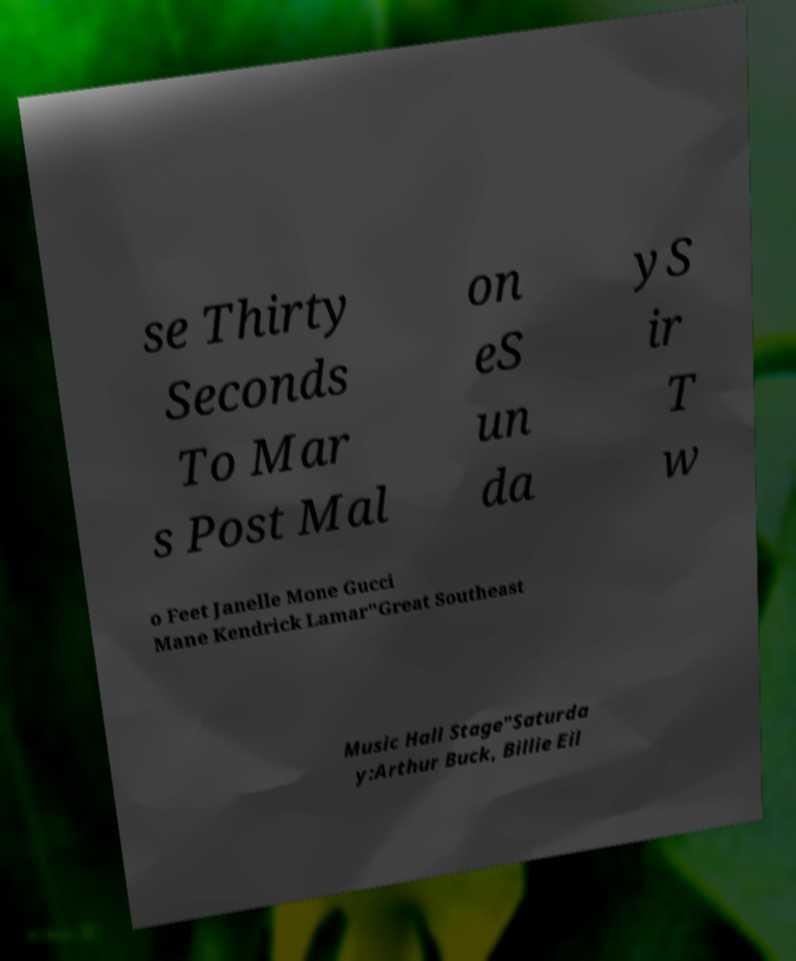I need the written content from this picture converted into text. Can you do that? se Thirty Seconds To Mar s Post Mal on eS un da yS ir T w o Feet Janelle Mone Gucci Mane Kendrick Lamar"Great Southeast Music Hall Stage"Saturda y:Arthur Buck, Billie Eil 